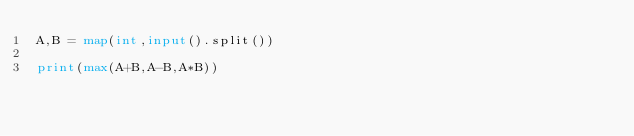<code> <loc_0><loc_0><loc_500><loc_500><_Python_>A,B = map(int,input().split())

print(max(A+B,A-B,A*B))</code> 